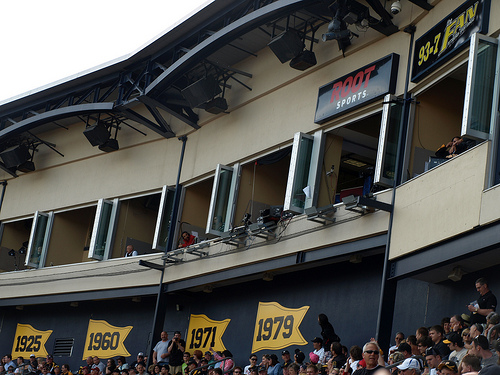<image>
Can you confirm if the sign is behind the speaker? Yes. From this viewpoint, the sign is positioned behind the speaker, with the speaker partially or fully occluding the sign. 